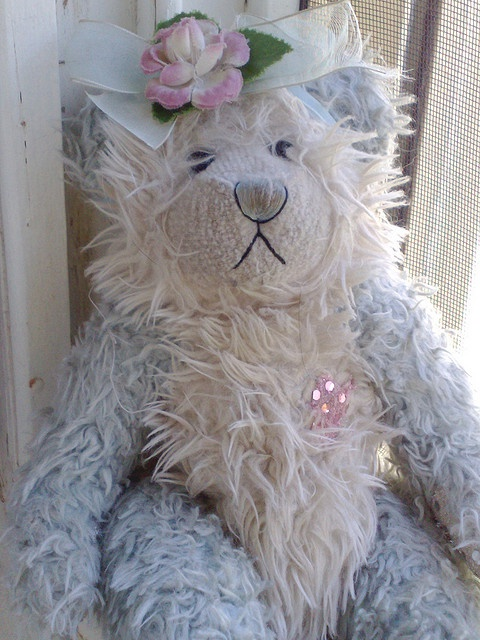Describe the objects in this image and their specific colors. I can see a teddy bear in darkgray, gray, and lightgray tones in this image. 